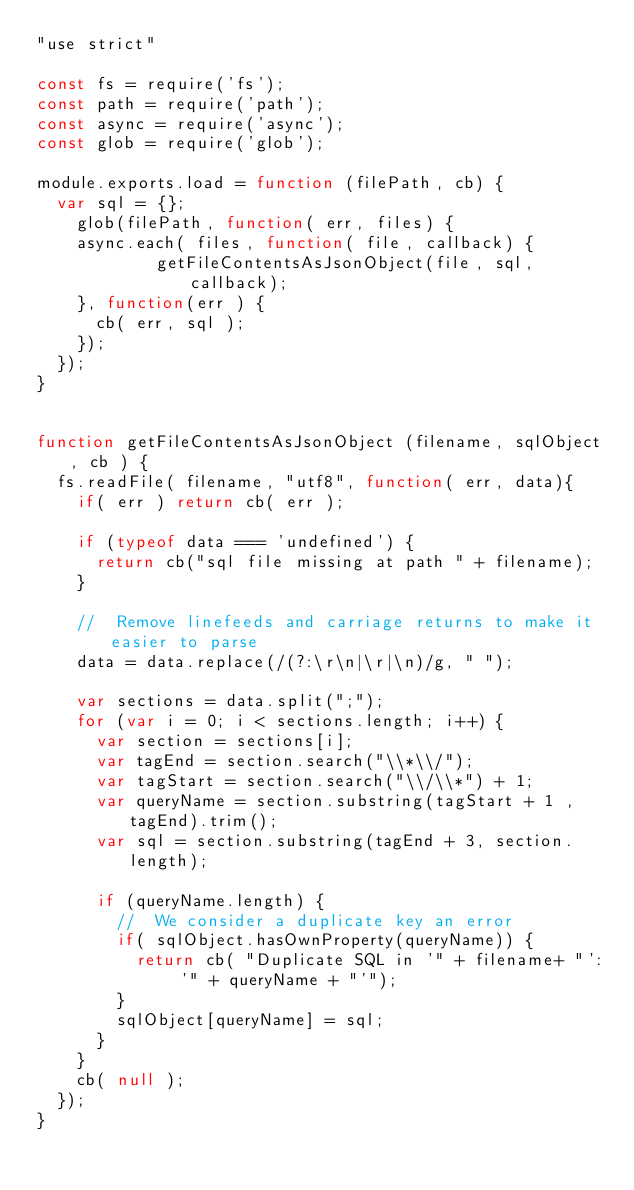Convert code to text. <code><loc_0><loc_0><loc_500><loc_500><_JavaScript_>"use strict"

const fs = require('fs');
const path = require('path');
const async = require('async');
const glob = require('glob');

module.exports.load = function (filePath, cb) {
	var sql = {};
    glob(filePath, function( err, files) {
		async.each( files, function( file, callback) {
            getFileContentsAsJsonObject(file, sql, callback);
		}, function(err ) {
			cb( err, sql );
		});
	});
}


function getFileContentsAsJsonObject (filename, sqlObject, cb ) {
	fs.readFile( filename, "utf8", function( err, data){
		if( err ) return cb( err );
	
		if (typeof data === 'undefined') {
			return cb("sql file missing at path " + filename);
		}
		
		//	Remove linefeeds and carriage returns to make it easier to parse
		data = data.replace(/(?:\r\n|\r|\n)/g, " ");

		var sections = data.split(";");
		for (var i = 0; i < sections.length; i++) {
			var section = sections[i];
			var tagEnd = section.search("\\*\\/");
			var tagStart = section.search("\\/\\*") + 1;
			var queryName = section.substring(tagStart + 1 , tagEnd).trim();
			var sql = section.substring(tagEnd + 3, section.length);
			
			if (queryName.length) {
				//	We consider a duplicate key an error
				if( sqlObject.hasOwnProperty(queryName)) {
					return cb( "Duplicate SQL in '" + filename+ "': '" + queryName + "'");
				}
				sqlObject[queryName] = sql;
			}
		}
		cb( null );
	});
}</code> 